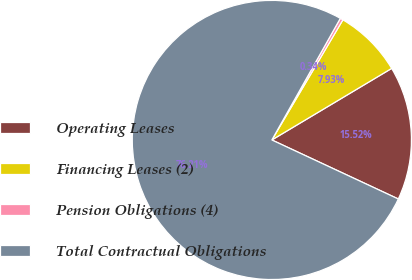Convert chart. <chart><loc_0><loc_0><loc_500><loc_500><pie_chart><fcel>Operating Leases<fcel>Financing Leases (2)<fcel>Pension Obligations (4)<fcel>Total Contractual Obligations<nl><fcel>15.52%<fcel>7.93%<fcel>0.34%<fcel>76.21%<nl></chart> 